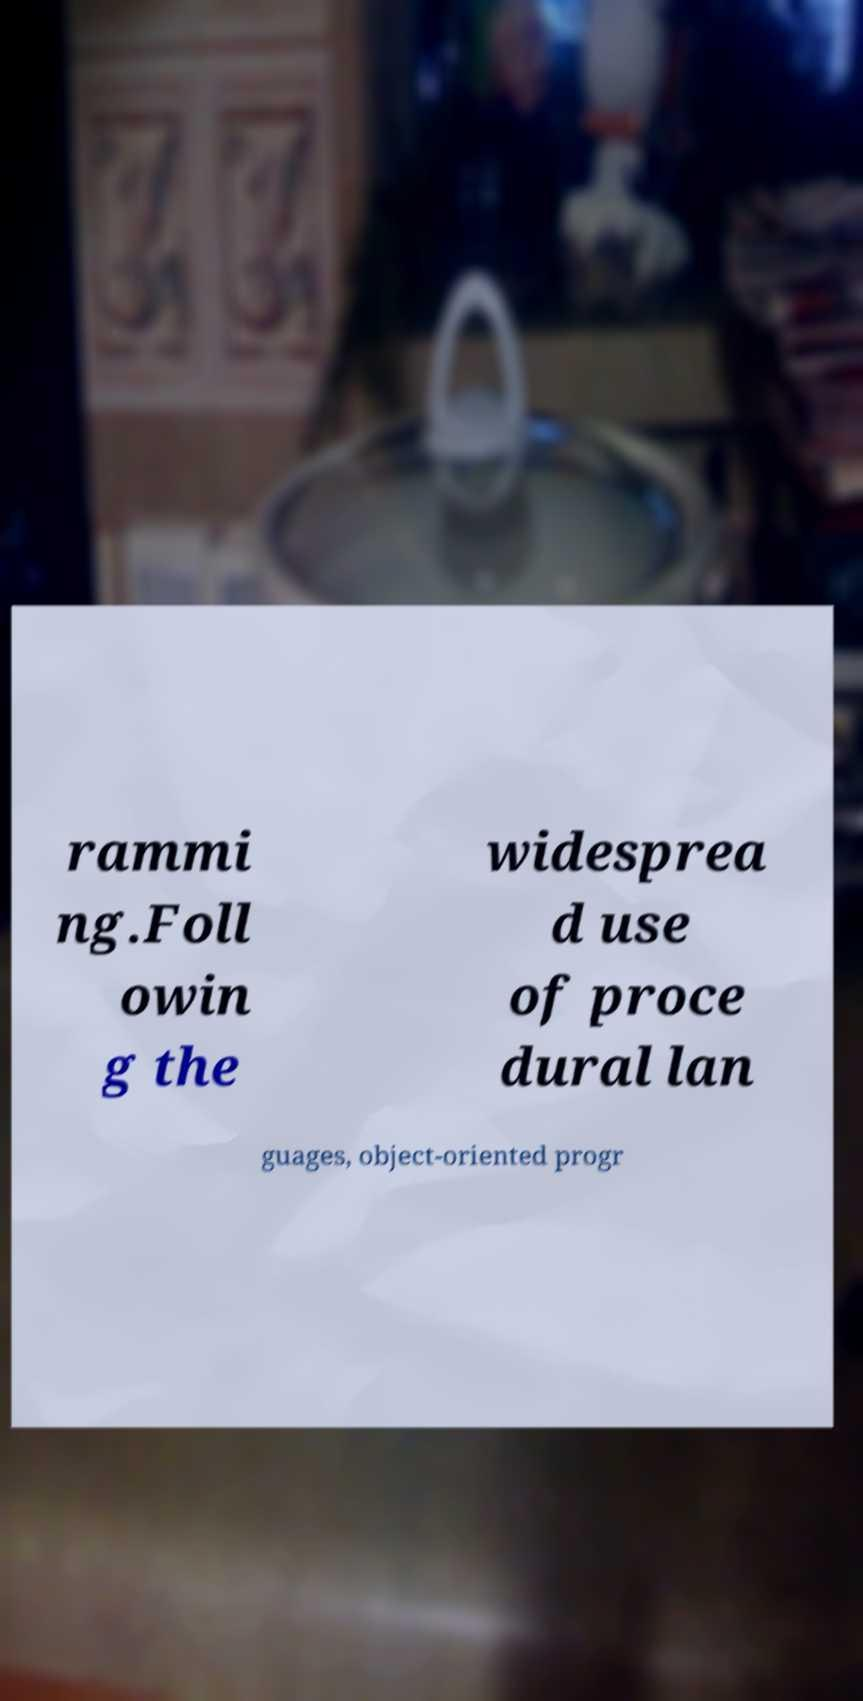There's text embedded in this image that I need extracted. Can you transcribe it verbatim? rammi ng.Foll owin g the widesprea d use of proce dural lan guages, object-oriented progr 